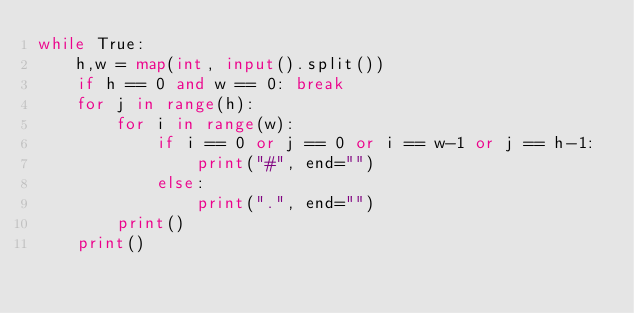Convert code to text. <code><loc_0><loc_0><loc_500><loc_500><_Python_>while True:
    h,w = map(int, input().split())
    if h == 0 and w == 0: break
    for j in range(h):
        for i in range(w):
            if i == 0 or j == 0 or i == w-1 or j == h-1:
                print("#", end="")
            else:
                print(".", end="")
        print()
    print()

</code> 